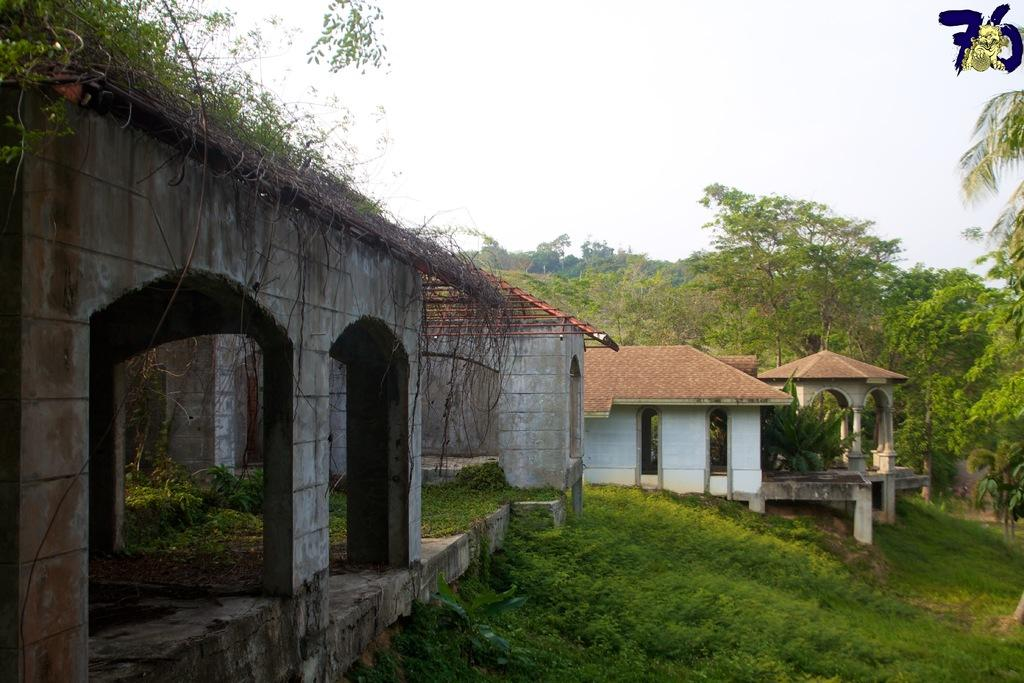What color are the roofs of the houses in the image? The roofs of the houses in the image are red. What type of vegetation can be seen at the bottom of the image? There is grass visible at the bottom of the image. What can be seen in the background of the image? There are many trees in the background of the image. What is visible at the top of the image? The sky is visible at the top of the image. What type of chair is placed near the trees in the image? There is no chair present near the trees in the image. 